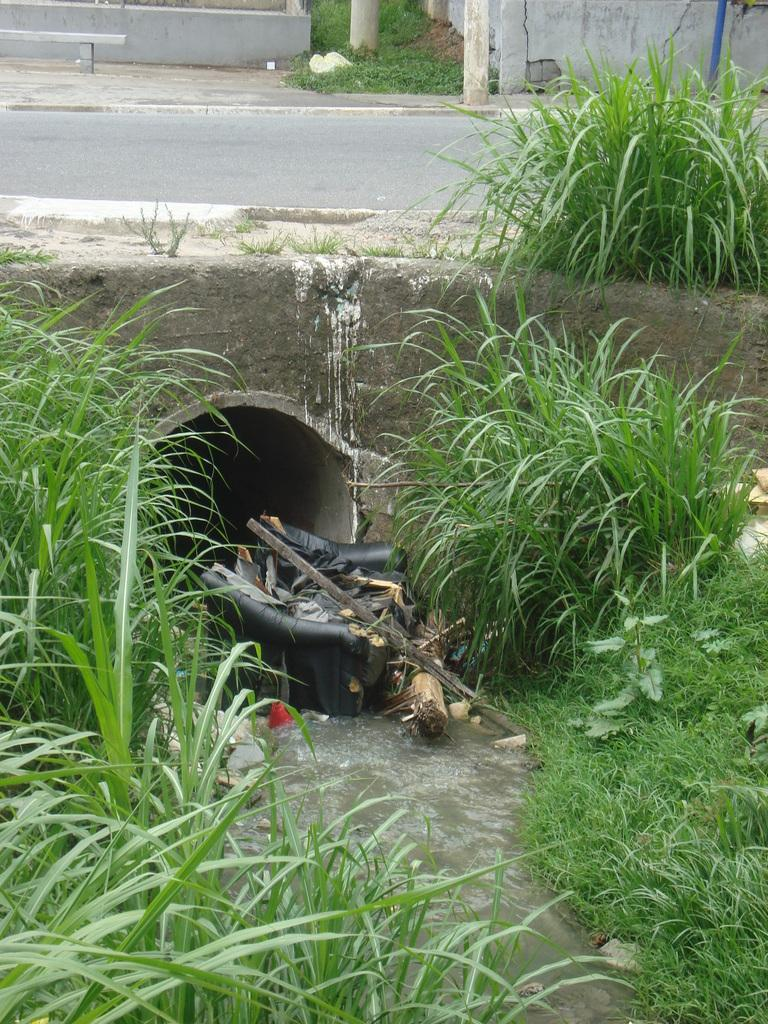What is floating in the water in the image? There is scrap in the water in the image. Where is the scrap located in relation to the tunnel? The scrap is located under a tunnel. What type of vegetation is present around the tunnel? Grass and bushes are present around the tunnel. What can be seen at the top of the image? There is a road visible at the top of the image. How many rabbits are hopping on the road in the image? There are no rabbits present in the image. What type of trousers is the scrap wearing in the image? The scrap is not a person and therefore does not wear trousers. 